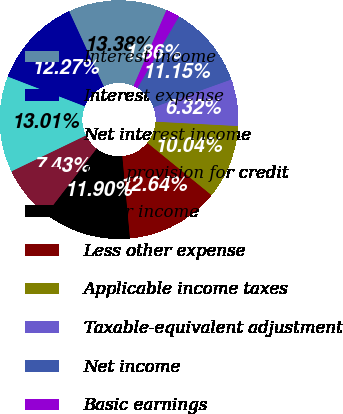<chart> <loc_0><loc_0><loc_500><loc_500><pie_chart><fcel>Interest income<fcel>Interest expense<fcel>Net interest income<fcel>Less provision for credit<fcel>Other income<fcel>Less other expense<fcel>Applicable income taxes<fcel>Taxable-equivalent adjustment<fcel>Net income<fcel>Basic earnings<nl><fcel>13.38%<fcel>12.27%<fcel>13.01%<fcel>7.43%<fcel>11.9%<fcel>12.64%<fcel>10.04%<fcel>6.32%<fcel>11.15%<fcel>1.86%<nl></chart> 